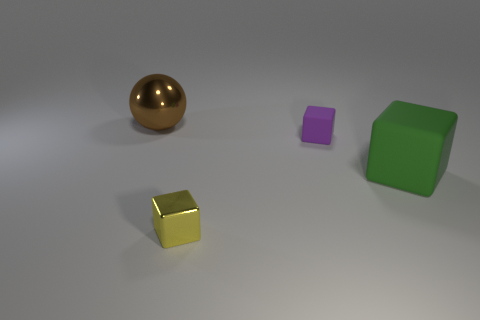Add 3 small brown balls. How many objects exist? 7 Subtract all spheres. How many objects are left? 3 Subtract all green things. Subtract all large green things. How many objects are left? 2 Add 4 balls. How many balls are left? 5 Add 1 tiny metallic things. How many tiny metallic things exist? 2 Subtract 0 cyan cubes. How many objects are left? 4 